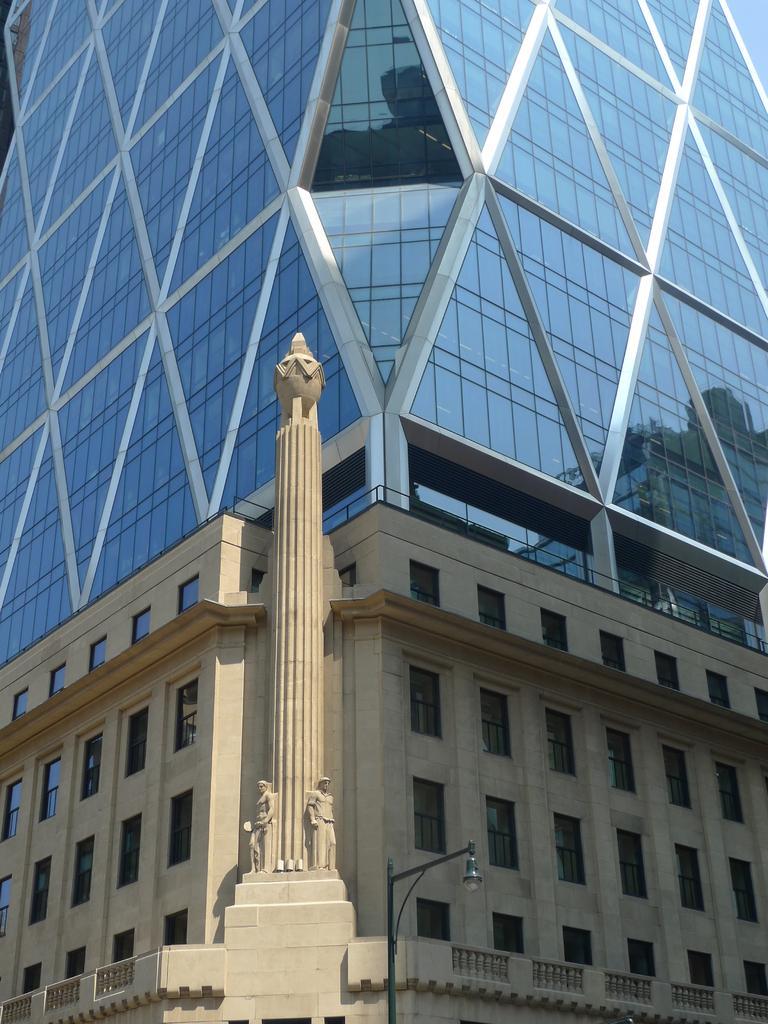Describe this image in one or two sentences. In the center of the image we can see pillar. In the background we can see buildings. At the bottom of the image there is light pole. 